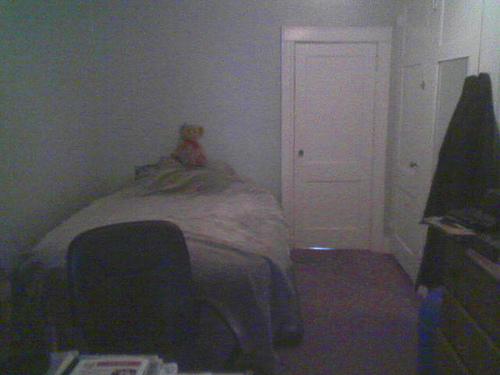What color is the pillow on the bed?
Short answer required. White. Where is the plastic chair?
Write a very short answer. By bed. Is the bed made?
Be succinct. Yes. Is the door on the left open or closed?
Be succinct. Closed. Is there a sheet on the bed?
Short answer required. Yes. What is the color of the bed cover?
Answer briefly. White. What room is this?
Give a very brief answer. Bedroom. What kind of doors are they?
Write a very short answer. Wooden. Is the door open?
Quick response, please. No. What color is the chair?
Be succinct. Black. What kind of lighting is shown?
Give a very brief answer. Dim. Where is the stuffed animal?
Give a very brief answer. Bed. What is the scientific name for a cat?
Keep it brief. Feline. 